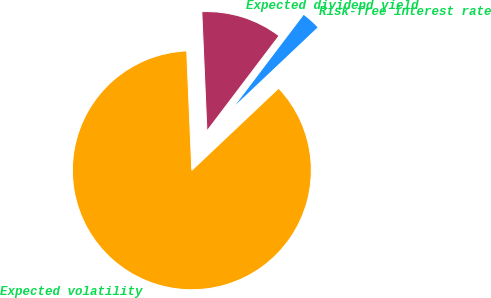Convert chart to OTSL. <chart><loc_0><loc_0><loc_500><loc_500><pie_chart><fcel>Risk-free interest rate<fcel>Expected dividend yield<fcel>Expected volatility<nl><fcel>2.63%<fcel>11.0%<fcel>86.37%<nl></chart> 